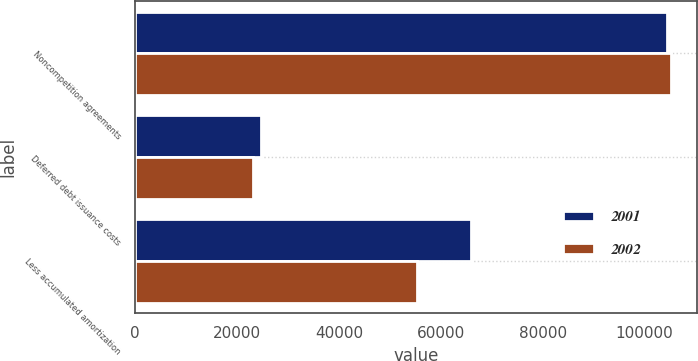Convert chart. <chart><loc_0><loc_0><loc_500><loc_500><stacked_bar_chart><ecel><fcel>Noncompetition agreements<fcel>Deferred debt issuance costs<fcel>Less accumulated amortization<nl><fcel>2001<fcel>104479<fcel>24666<fcel>65986<nl><fcel>2002<fcel>105130<fcel>23195<fcel>55217<nl></chart> 